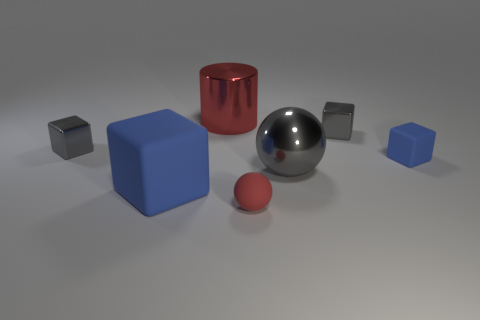Are there any other things that have the same shape as the red shiny object? If by 'shape' we mean the general geometric form, then yes, the red shiny object, which is a cylinder, shares its general shape with the object that appears slightly behind and to the left, although that object is less reflective and has a different color. 